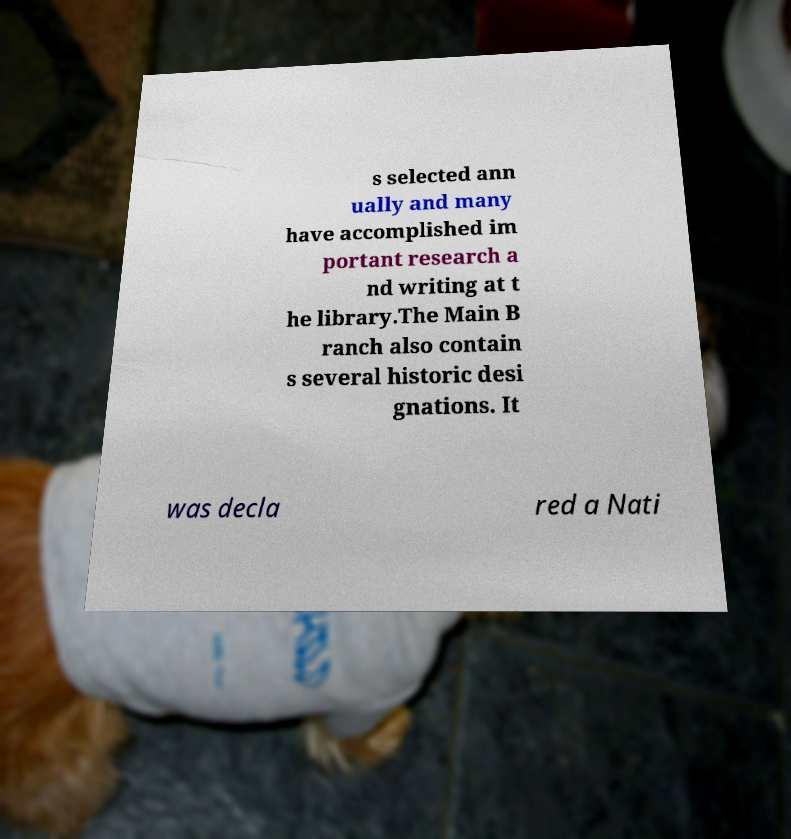Could you assist in decoding the text presented in this image and type it out clearly? s selected ann ually and many have accomplished im portant research a nd writing at t he library.The Main B ranch also contain s several historic desi gnations. It was decla red a Nati 